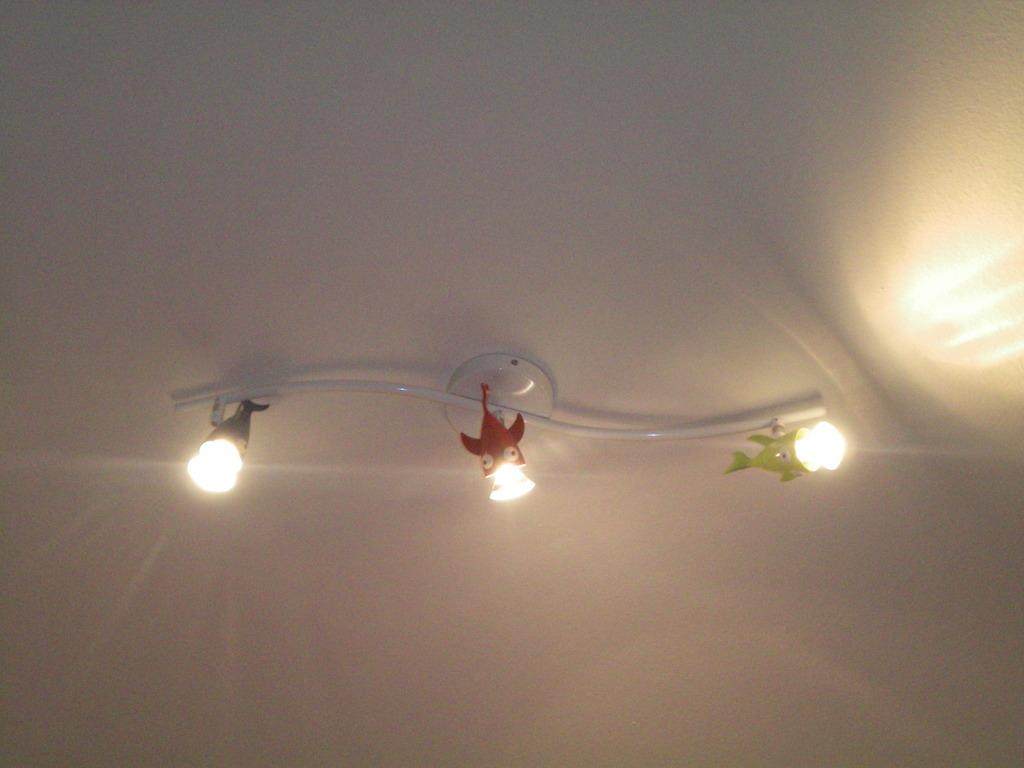What is hanging from the ceiling in the image? There are lights on the ceiling in the image. How are the lights arranged or connected? The lights are in a hanger. What type of nerve can be seen in the image? There is no nerve present in the image; it features lights hanging from the ceiling. Are there any jeans visible in the image? There are no jeans present in the image. 